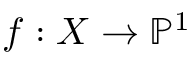<formula> <loc_0><loc_0><loc_500><loc_500>f \colon X \to \mathbb { P } ^ { 1 }</formula> 